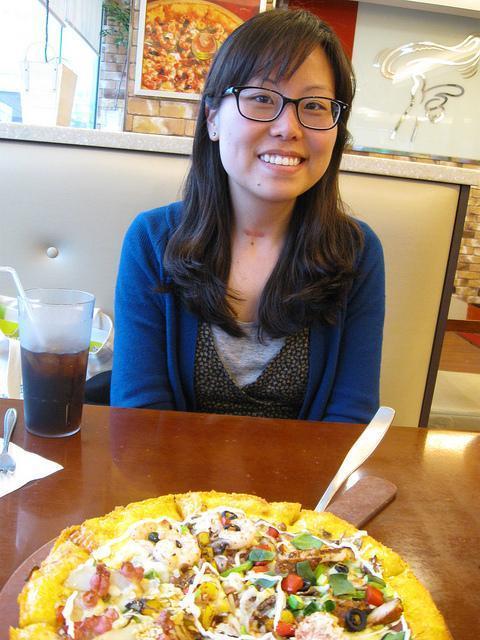How many dining tables can you see?
Give a very brief answer. 1. How many cups are in the picture?
Give a very brief answer. 1. How many blue airplanes are in the image?
Give a very brief answer. 0. 